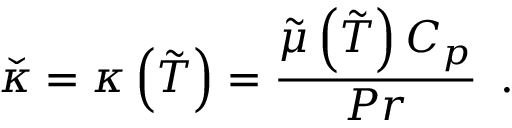<formula> <loc_0><loc_0><loc_500><loc_500>\check { \kappa } = \kappa \left ( \tilde { T } \right ) = \frac { \tilde { \mu } \left ( \tilde { T } \right ) C _ { p } } { P r } \, .</formula> 